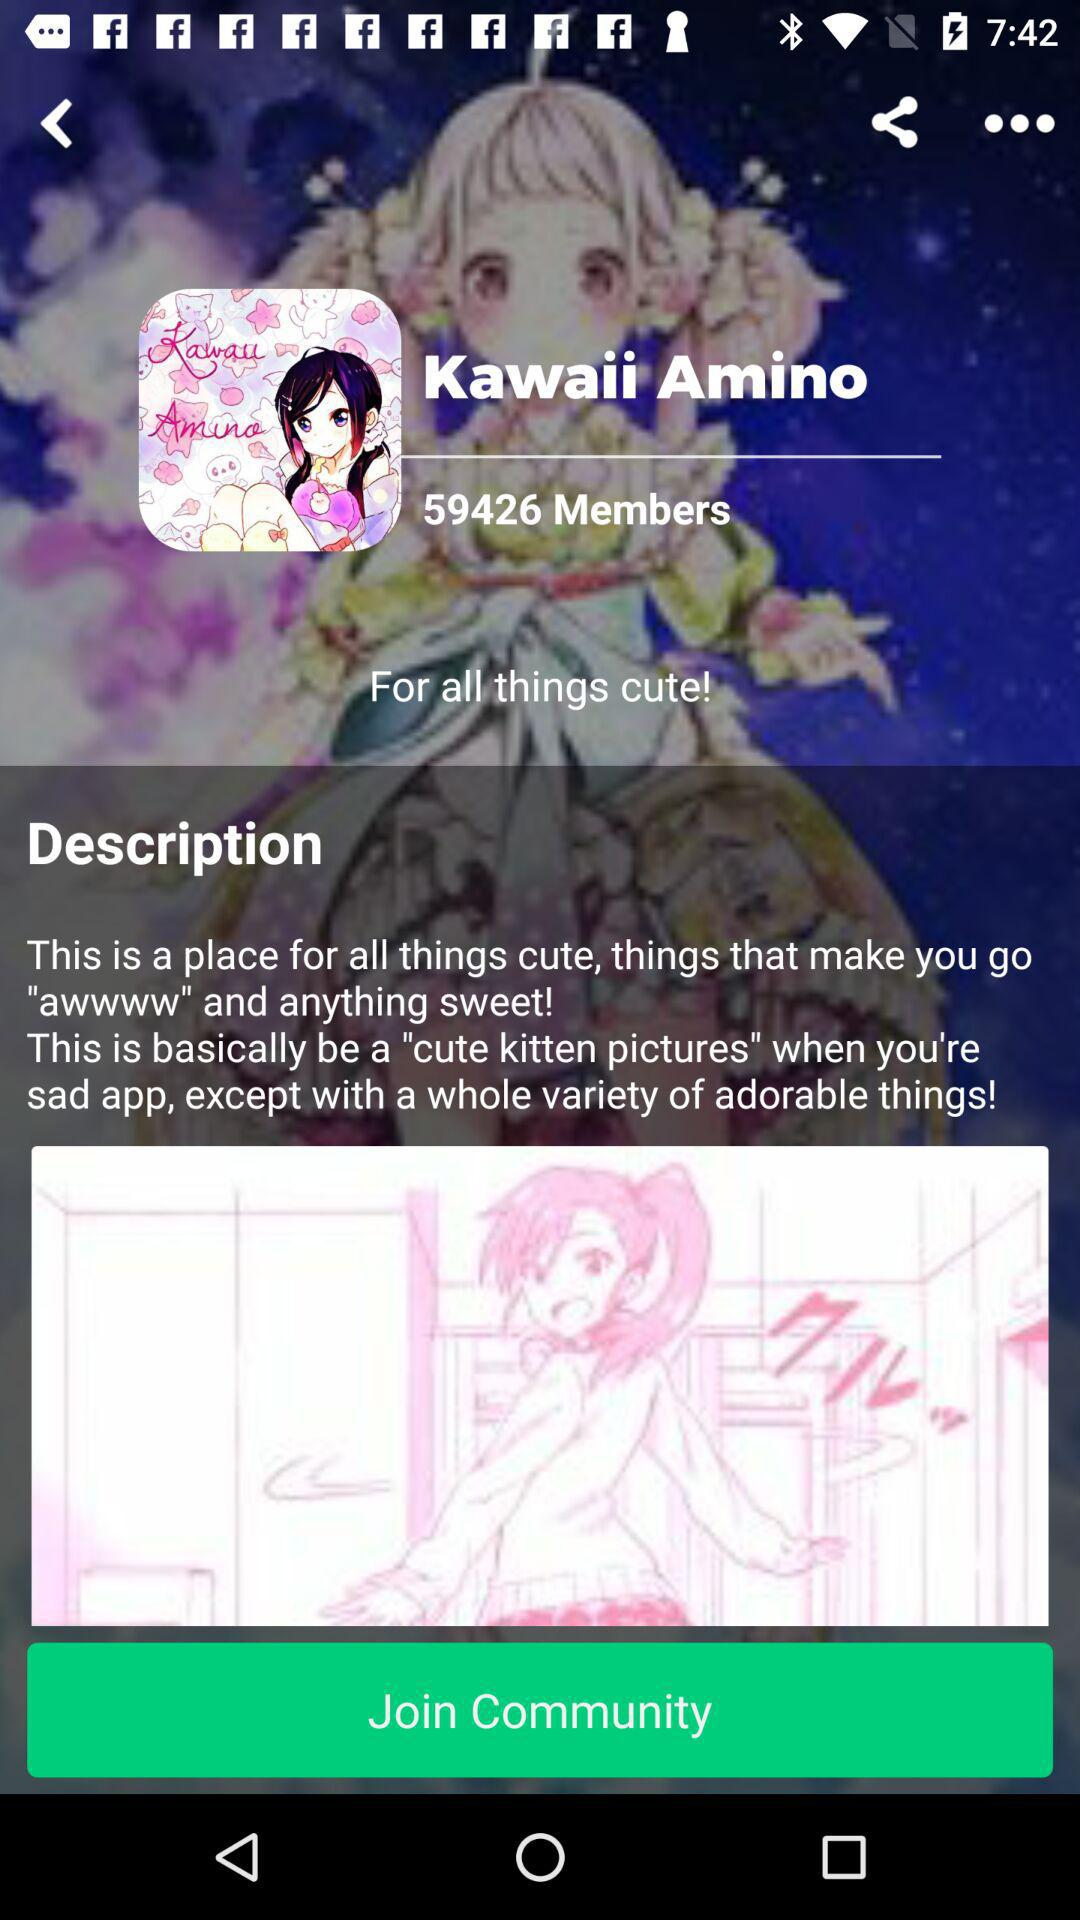How many members are in "Kawaii Amino"? There are 59426 members in "Kawaii Amino". 